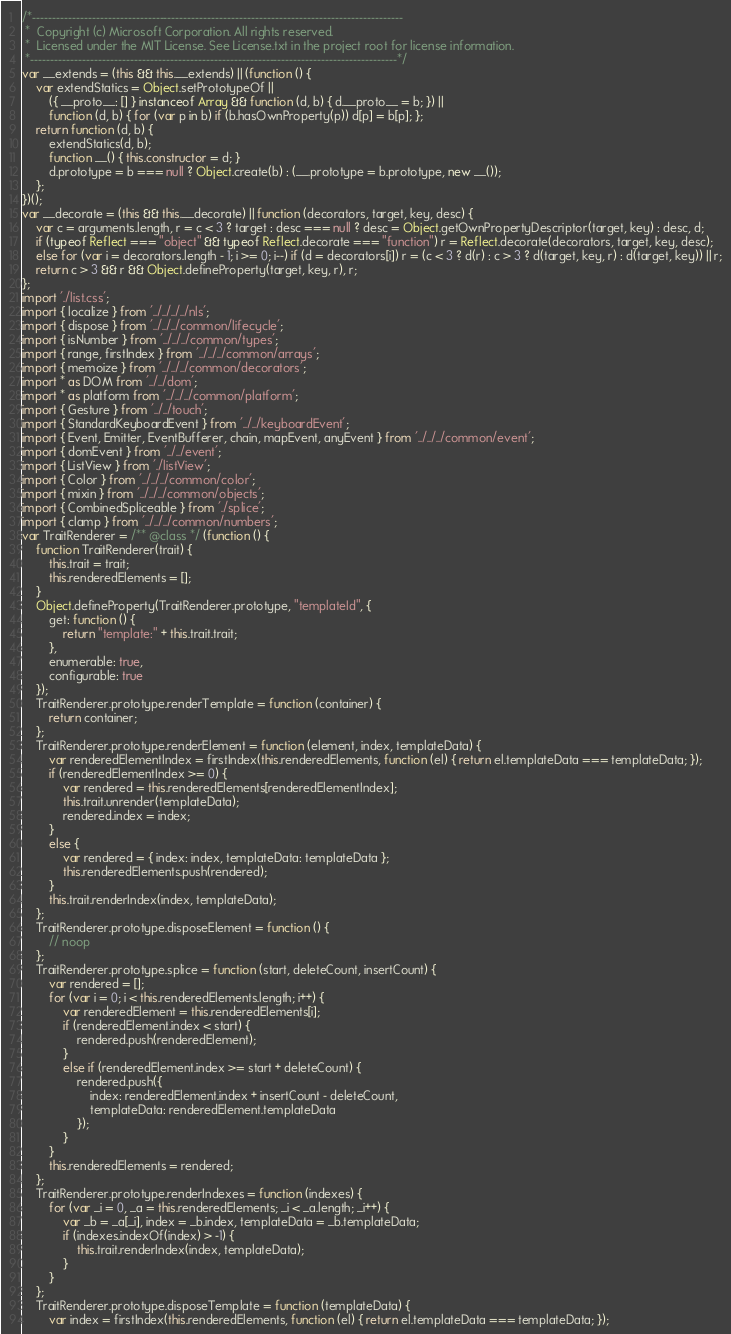<code> <loc_0><loc_0><loc_500><loc_500><_JavaScript_>/*---------------------------------------------------------------------------------------------
 *  Copyright (c) Microsoft Corporation. All rights reserved.
 *  Licensed under the MIT License. See License.txt in the project root for license information.
 *--------------------------------------------------------------------------------------------*/
var __extends = (this && this.__extends) || (function () {
    var extendStatics = Object.setPrototypeOf ||
        ({ __proto__: [] } instanceof Array && function (d, b) { d.__proto__ = b; }) ||
        function (d, b) { for (var p in b) if (b.hasOwnProperty(p)) d[p] = b[p]; };
    return function (d, b) {
        extendStatics(d, b);
        function __() { this.constructor = d; }
        d.prototype = b === null ? Object.create(b) : (__.prototype = b.prototype, new __());
    };
})();
var __decorate = (this && this.__decorate) || function (decorators, target, key, desc) {
    var c = arguments.length, r = c < 3 ? target : desc === null ? desc = Object.getOwnPropertyDescriptor(target, key) : desc, d;
    if (typeof Reflect === "object" && typeof Reflect.decorate === "function") r = Reflect.decorate(decorators, target, key, desc);
    else for (var i = decorators.length - 1; i >= 0; i--) if (d = decorators[i]) r = (c < 3 ? d(r) : c > 3 ? d(target, key, r) : d(target, key)) || r;
    return c > 3 && r && Object.defineProperty(target, key, r), r;
};
import './list.css';
import { localize } from '../../../../nls';
import { dispose } from '../../../common/lifecycle';
import { isNumber } from '../../../common/types';
import { range, firstIndex } from '../../../common/arrays';
import { memoize } from '../../../common/decorators';
import * as DOM from '../../dom';
import * as platform from '../../../common/platform';
import { Gesture } from '../../touch';
import { StandardKeyboardEvent } from '../../keyboardEvent';
import { Event, Emitter, EventBufferer, chain, mapEvent, anyEvent } from '../../../common/event';
import { domEvent } from '../../event';
import { ListView } from './listView';
import { Color } from '../../../common/color';
import { mixin } from '../../../common/objects';
import { CombinedSpliceable } from './splice';
import { clamp } from '../../../common/numbers';
var TraitRenderer = /** @class */ (function () {
    function TraitRenderer(trait) {
        this.trait = trait;
        this.renderedElements = [];
    }
    Object.defineProperty(TraitRenderer.prototype, "templateId", {
        get: function () {
            return "template:" + this.trait.trait;
        },
        enumerable: true,
        configurable: true
    });
    TraitRenderer.prototype.renderTemplate = function (container) {
        return container;
    };
    TraitRenderer.prototype.renderElement = function (element, index, templateData) {
        var renderedElementIndex = firstIndex(this.renderedElements, function (el) { return el.templateData === templateData; });
        if (renderedElementIndex >= 0) {
            var rendered = this.renderedElements[renderedElementIndex];
            this.trait.unrender(templateData);
            rendered.index = index;
        }
        else {
            var rendered = { index: index, templateData: templateData };
            this.renderedElements.push(rendered);
        }
        this.trait.renderIndex(index, templateData);
    };
    TraitRenderer.prototype.disposeElement = function () {
        // noop
    };
    TraitRenderer.prototype.splice = function (start, deleteCount, insertCount) {
        var rendered = [];
        for (var i = 0; i < this.renderedElements.length; i++) {
            var renderedElement = this.renderedElements[i];
            if (renderedElement.index < start) {
                rendered.push(renderedElement);
            }
            else if (renderedElement.index >= start + deleteCount) {
                rendered.push({
                    index: renderedElement.index + insertCount - deleteCount,
                    templateData: renderedElement.templateData
                });
            }
        }
        this.renderedElements = rendered;
    };
    TraitRenderer.prototype.renderIndexes = function (indexes) {
        for (var _i = 0, _a = this.renderedElements; _i < _a.length; _i++) {
            var _b = _a[_i], index = _b.index, templateData = _b.templateData;
            if (indexes.indexOf(index) > -1) {
                this.trait.renderIndex(index, templateData);
            }
        }
    };
    TraitRenderer.prototype.disposeTemplate = function (templateData) {
        var index = firstIndex(this.renderedElements, function (el) { return el.templateData === templateData; });</code> 